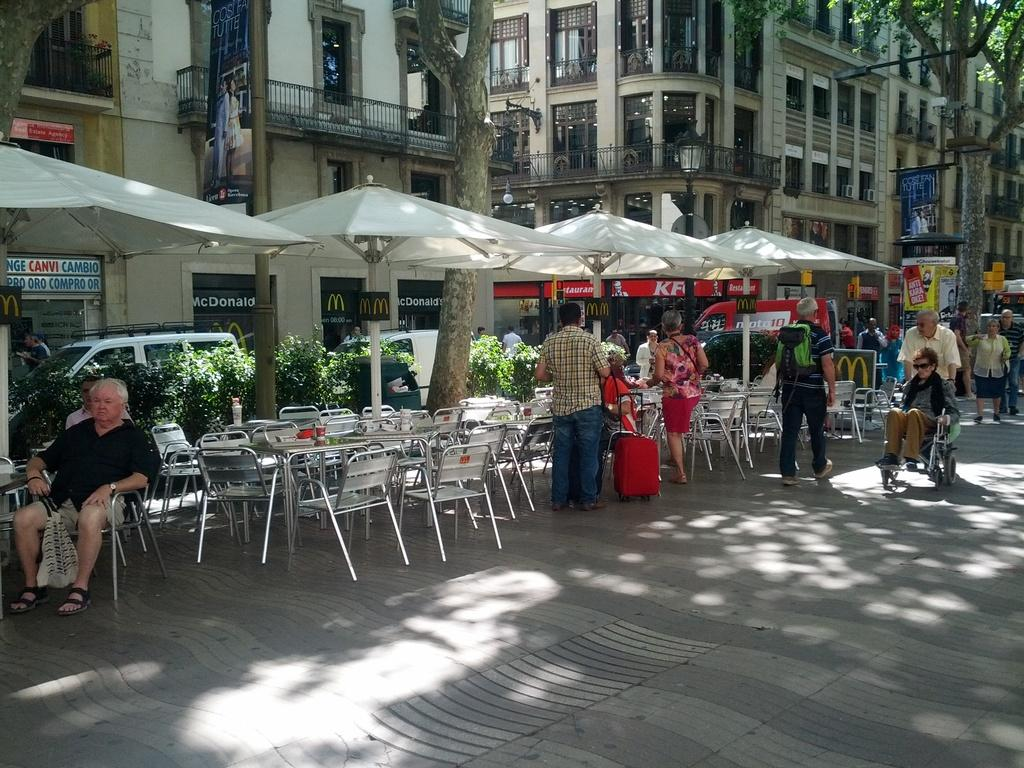What type of structures can be seen in the image? There are buildings in the image. What natural elements are present in the image? There are trees in the image. What type of furniture is visible in the image? There are chairs and tables in the image. Are there any individuals present in the image? Yes, there are people present in the image. What color is the sweater worn by the person on the left page of the image? There is no sweater or page present in the image; it features buildings, trees, chairs, tables, and people. 